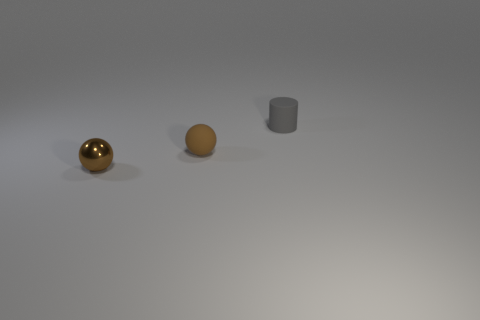Is there a rubber ball?
Give a very brief answer. Yes. What size is the brown sphere that is made of the same material as the small cylinder?
Make the answer very short. Small. What number of other objects are there of the same material as the tiny cylinder?
Offer a terse response. 1. How many things are both behind the small brown shiny sphere and on the left side of the tiny gray object?
Your response must be concise. 1. The small metallic ball is what color?
Provide a short and direct response. Brown. There is another small object that is the same shape as the brown rubber object; what is it made of?
Your answer should be compact. Metal. Is there any other thing that is the same material as the tiny cylinder?
Your response must be concise. Yes. Does the shiny ball have the same color as the cylinder?
Ensure brevity in your answer.  No. There is a tiny brown object behind the ball that is in front of the brown rubber object; what shape is it?
Give a very brief answer. Sphere. What number of other things are there of the same shape as the tiny metallic thing?
Give a very brief answer. 1. 